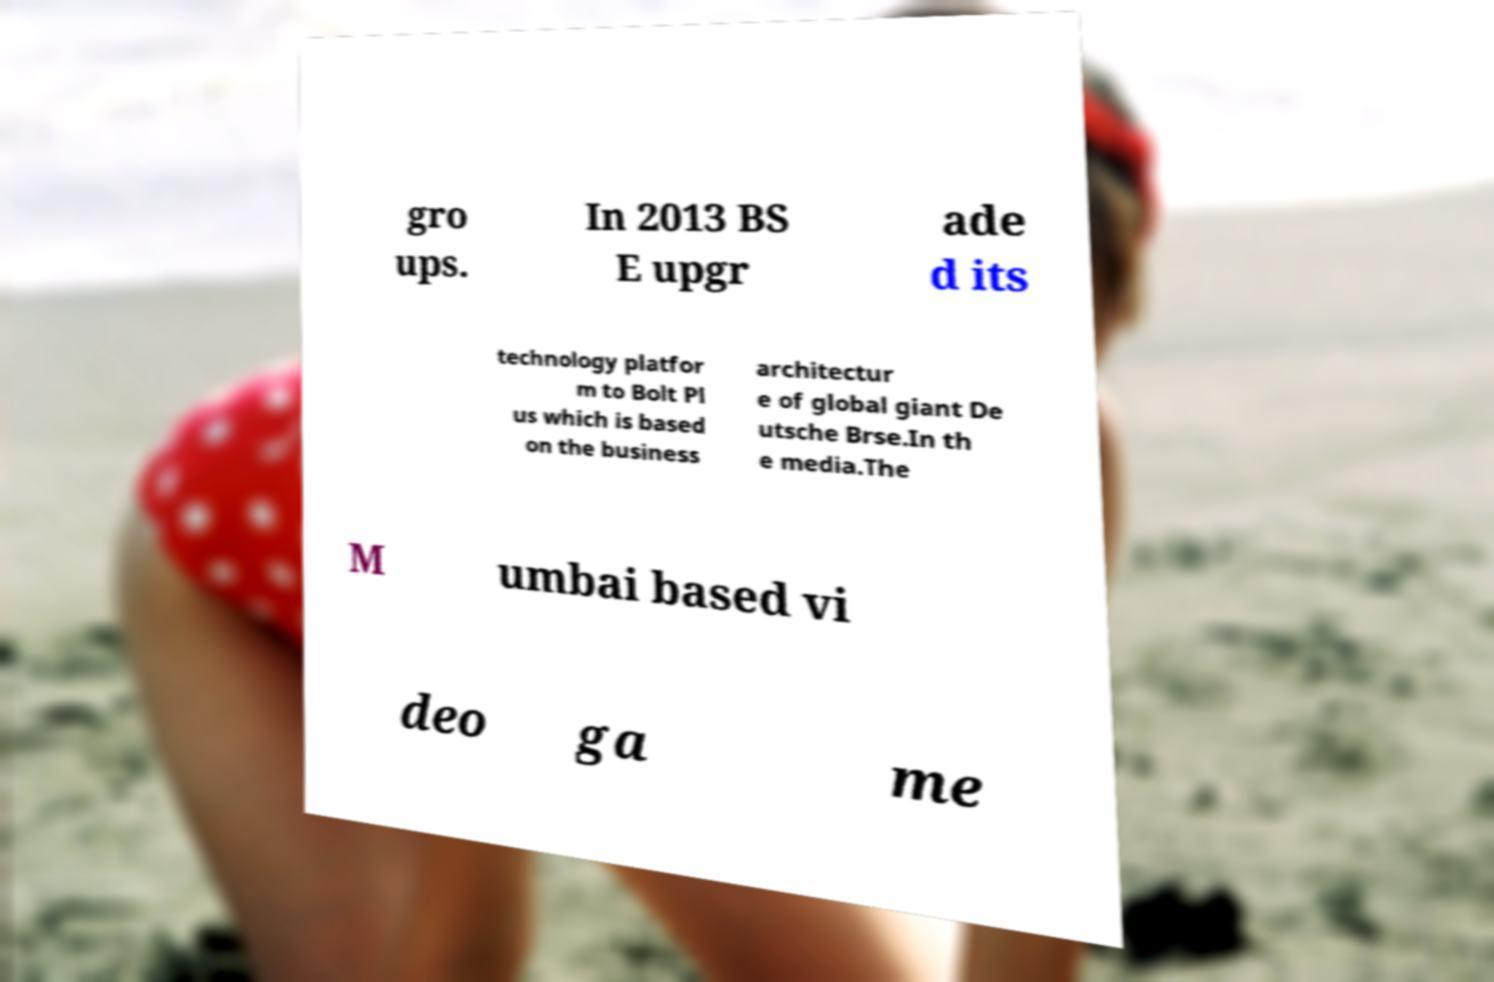Can you read and provide the text displayed in the image?This photo seems to have some interesting text. Can you extract and type it out for me? gro ups. In 2013 BS E upgr ade d its technology platfor m to Bolt Pl us which is based on the business architectur e of global giant De utsche Brse.In th e media.The M umbai based vi deo ga me 